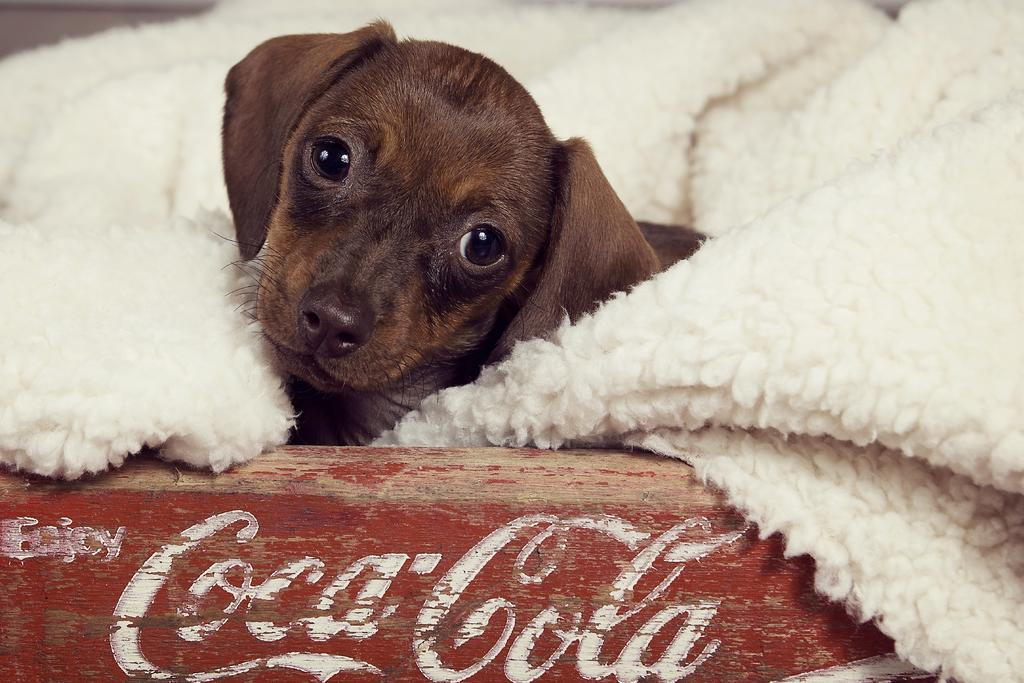What type of animal is in the image? There is a brown puppy in the image. What is the puppy resting on or surrounded by? The brown puppy is surrounded by a white blanket. What type of art can be seen on the puppy's nose in the image? There is no art visible on the puppy's nose in the image. What type of mint is present in the image? There is no mint present in the image. 